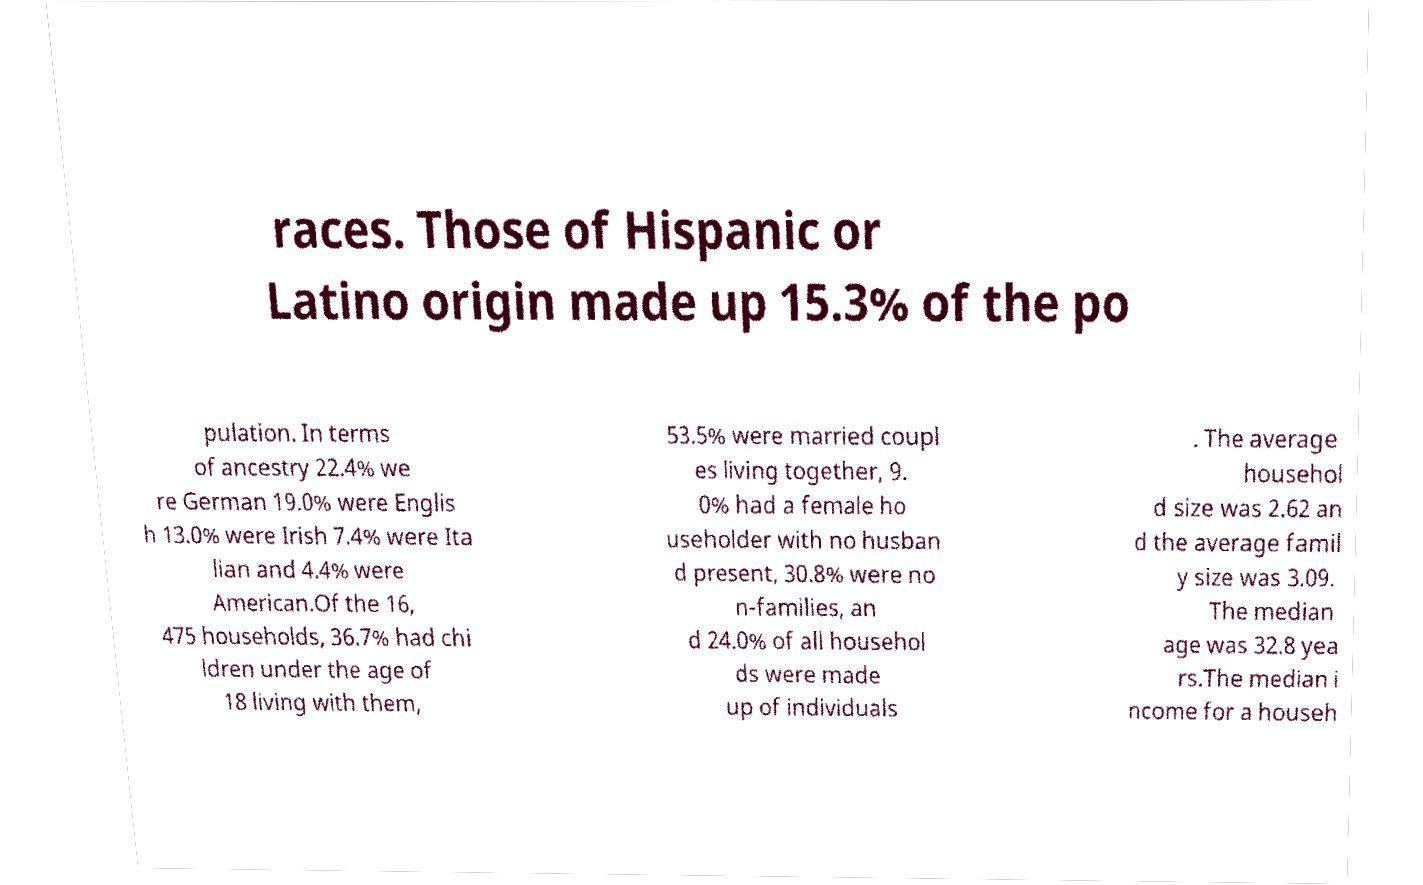I need the written content from this picture converted into text. Can you do that? races. Those of Hispanic or Latino origin made up 15.3% of the po pulation. In terms of ancestry 22.4% we re German 19.0% were Englis h 13.0% were Irish 7.4% were Ita lian and 4.4% were American.Of the 16, 475 households, 36.7% had chi ldren under the age of 18 living with them, 53.5% were married coupl es living together, 9. 0% had a female ho useholder with no husban d present, 30.8% were no n-families, an d 24.0% of all househol ds were made up of individuals . The average househol d size was 2.62 an d the average famil y size was 3.09. The median age was 32.8 yea rs.The median i ncome for a househ 